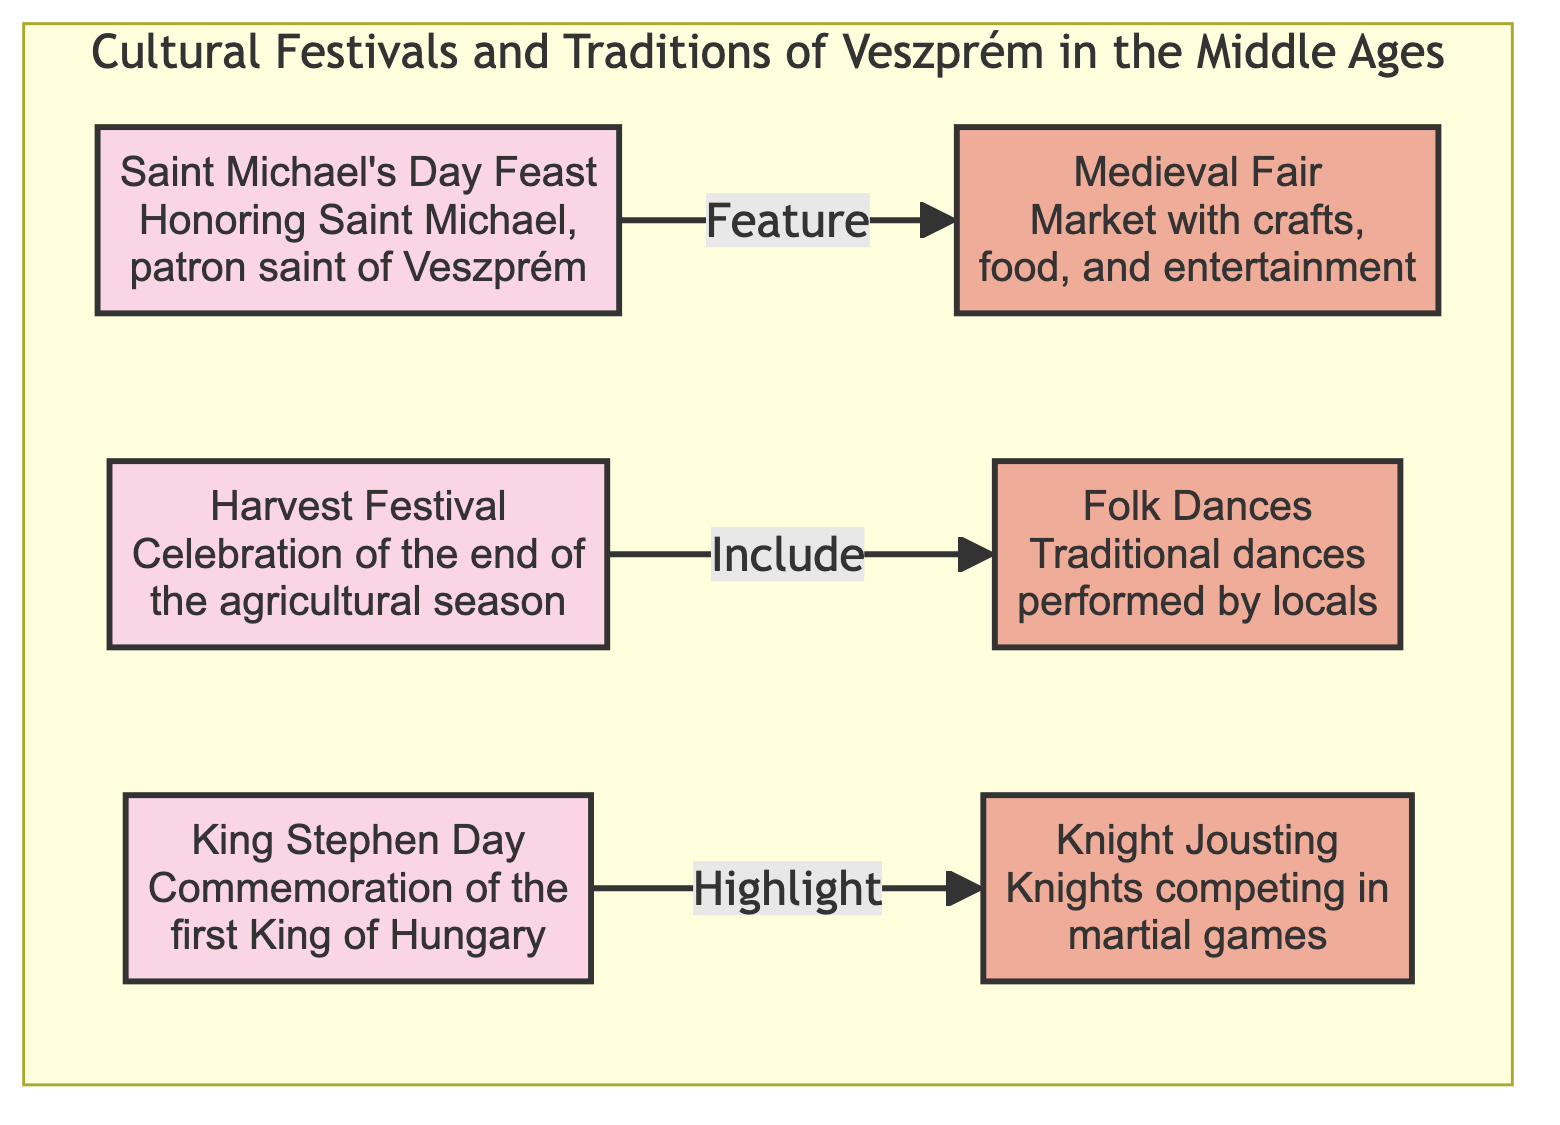What is the first event listed in the diagram? The first event is located at the top of the subgraph, labeled "Saint Michael's Day Feast".
Answer: Saint Michael's Day Feast How many events are depicted in the diagram? The diagram shows three events total; these are highlighted under the cultural festivals.
Answer: 3 What tradition is included in the Harvest Festival? The relationship linking the Harvest Festival suggests it includes "Folk Dances".
Answer: Folk Dances Which event highlights traditional knight jousting? The King Stephen Day mentions a connection to knight jousting, highlighting its significance in this context.
Answer: King Stephen Day What is the relationship between the Saint Michael's Day Feast and the Medieval Fair? The Saint Michael's Day Feast directly features the Medieval Fair, indicating a significant connection between the two.
Answer: Features Which tradition is performed by locals? Folk Dances is specifically mentioned as a traditional dance that is performed by the local community.
Answer: Folk Dances What section of the diagram do the events belong to? All three events are categorized under "Cultural Festivals and Traditions of Veszprém in the Middle Ages".
Answer: Cultural Festivals and Traditions of Veszprém in the Middle Ages Which event commemorates the first King of Hungary? The event titled "King Stephen Day" commemorates Hungary's first king.
Answer: King Stephen Day What color denotes the event nodes in the diagram? The nodes representing events are filled with a light pink color designated by the class "eventClass".
Answer: Light pink 